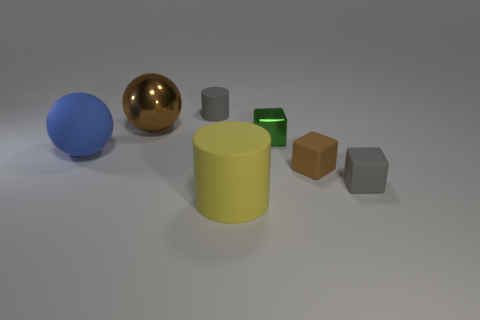Subtract all blue blocks. Subtract all green cylinders. How many blocks are left? 3 Add 2 large cylinders. How many objects exist? 9 Subtract all blocks. How many objects are left? 4 Subtract all yellow cylinders. Subtract all brown shiny spheres. How many objects are left? 5 Add 3 tiny green metal cubes. How many tiny green metal cubes are left? 4 Add 1 green metal cubes. How many green metal cubes exist? 2 Subtract 1 brown spheres. How many objects are left? 6 